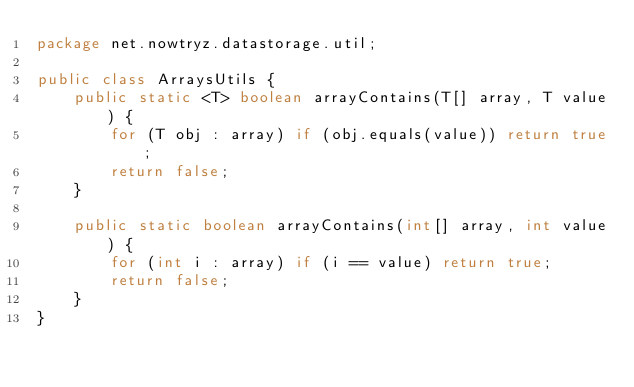<code> <loc_0><loc_0><loc_500><loc_500><_Java_>package net.nowtryz.datastorage.util;

public class ArraysUtils {
    public static <T> boolean arrayContains(T[] array, T value) {
        for (T obj : array) if (obj.equals(value)) return true;
        return false;
    }

    public static boolean arrayContains(int[] array, int value) {
        for (int i : array) if (i == value) return true;
        return false;
    }
}
</code> 